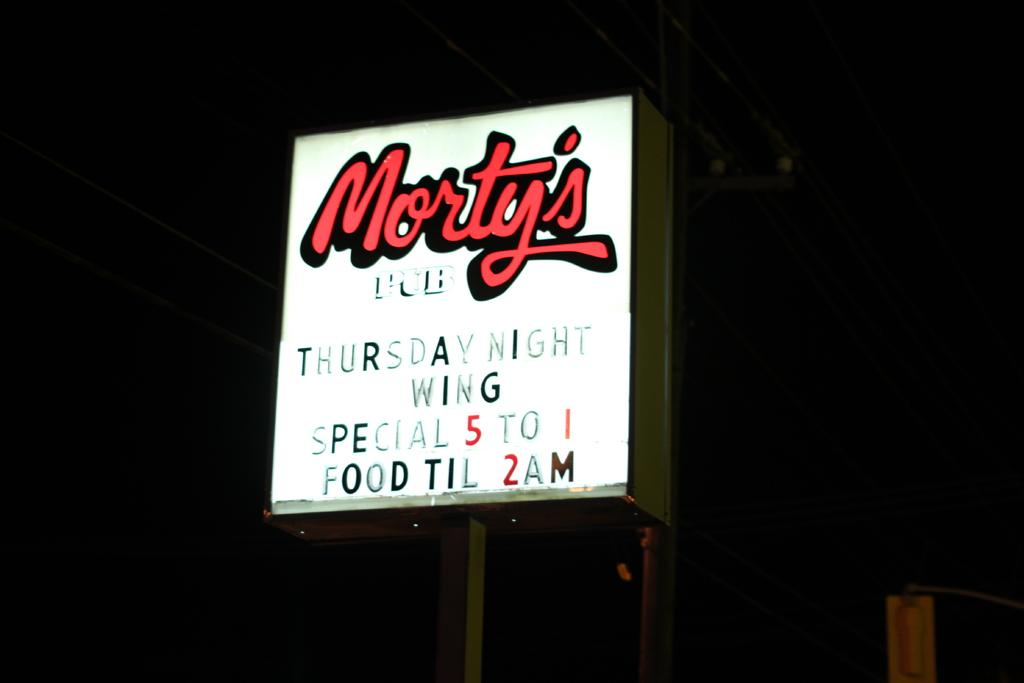Provide a one-sentence caption for the provided image. Morty's thursday night wing special on a banner outside. 